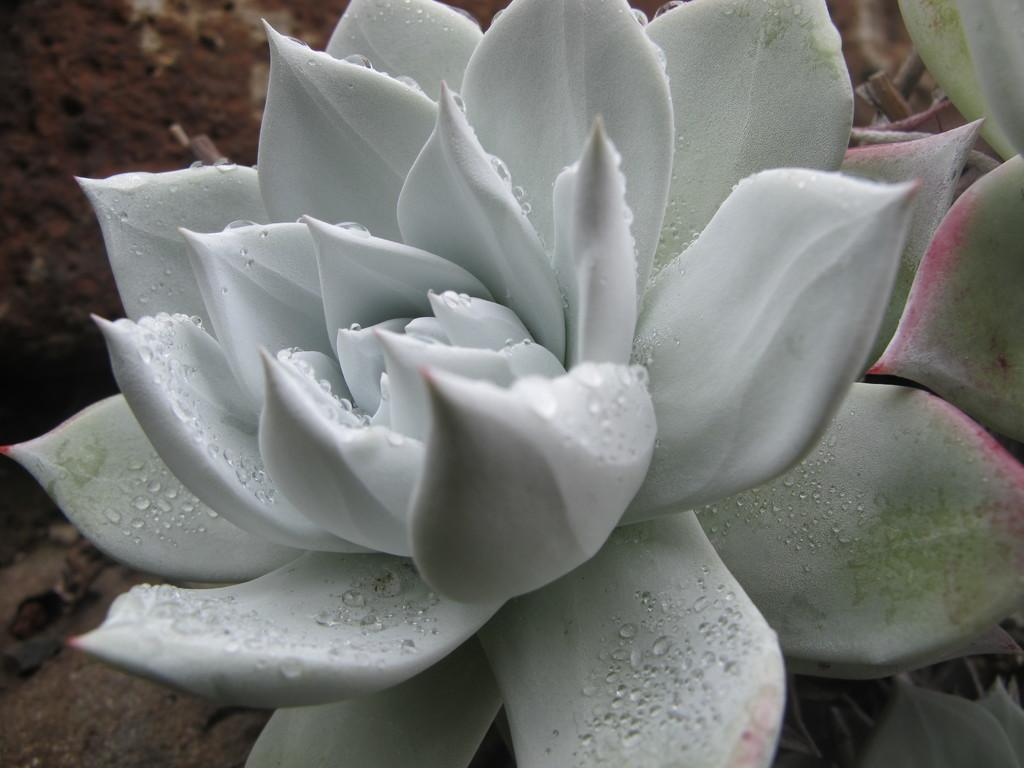What type of flowers can be seen in the image? There are white color flowers in the image. Are there any additional features on the flowers? Yes, there are water drops on the flowers. What can be seen on the left side of the image? There is land visible on the left side of the image. How many stars can be seen in the image? There are no stars present in the image. What is the fifth element in the image? The provided facts do not mention a fifth element, and there are only three elements described: white color flowers, water drops, and land. 